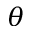<formula> <loc_0><loc_0><loc_500><loc_500>\theta</formula> 